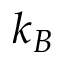<formula> <loc_0><loc_0><loc_500><loc_500>k _ { B }</formula> 